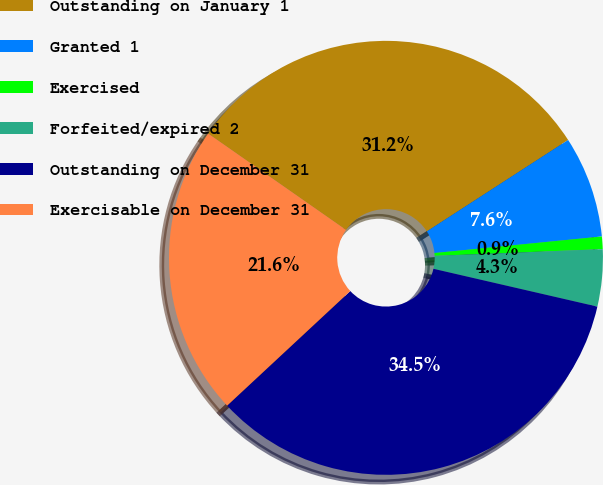<chart> <loc_0><loc_0><loc_500><loc_500><pie_chart><fcel>Outstanding on January 1<fcel>Granted 1<fcel>Exercised<fcel>Forfeited/expired 2<fcel>Outstanding on December 31<fcel>Exercisable on December 31<nl><fcel>31.15%<fcel>7.57%<fcel>0.93%<fcel>4.25%<fcel>34.46%<fcel>21.63%<nl></chart> 